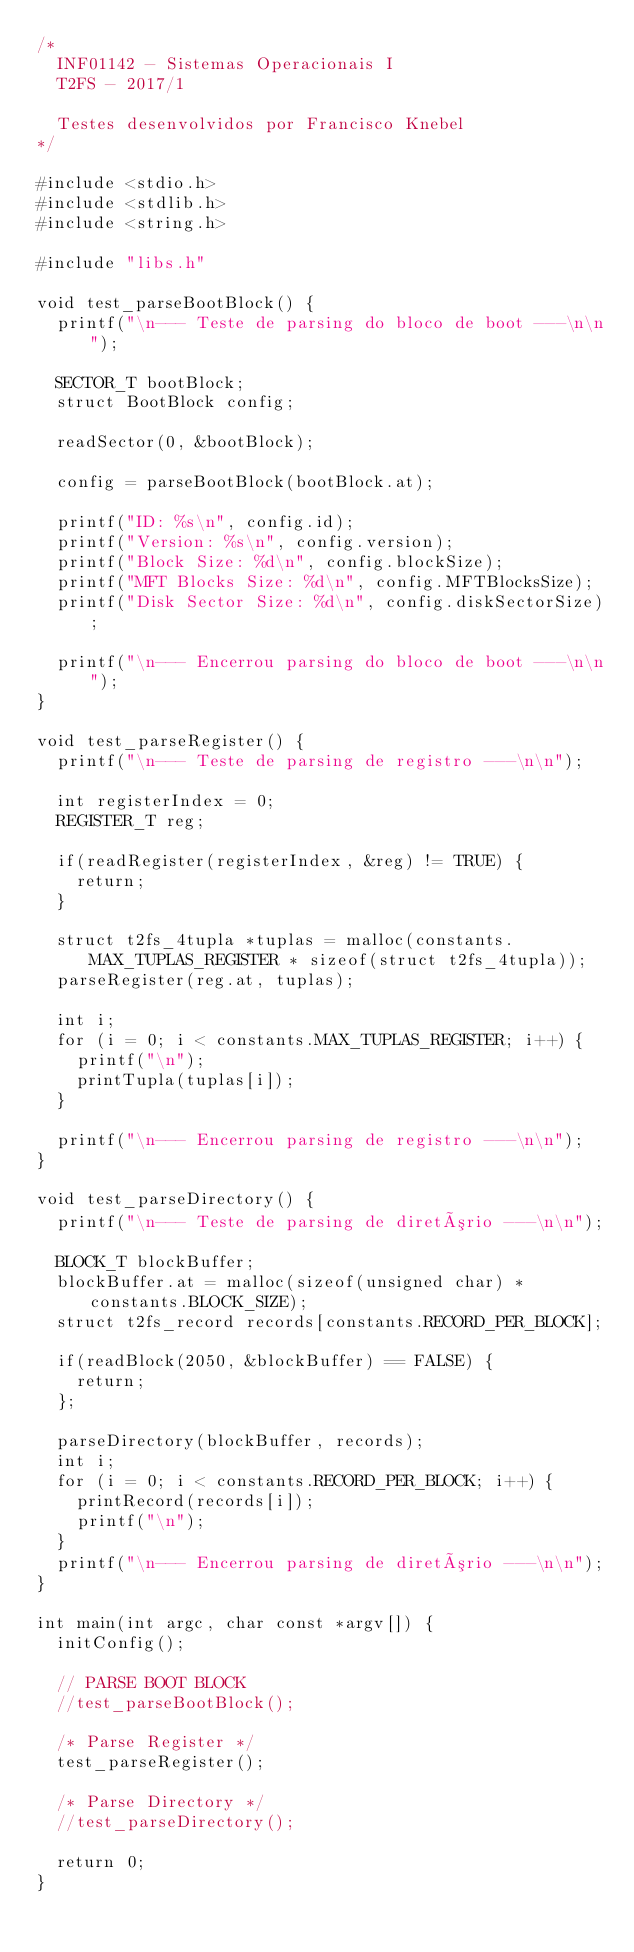Convert code to text. <code><loc_0><loc_0><loc_500><loc_500><_C_>/*
  INF01142 - Sistemas Operacionais I
  T2FS - 2017/1

  Testes desenvolvidos por Francisco Knebel
*/

#include <stdio.h>
#include <stdlib.h>
#include <string.h>

#include "libs.h"

void test_parseBootBlock() {
  printf("\n--- Teste de parsing do bloco de boot ---\n\n");

  SECTOR_T bootBlock;
  struct BootBlock config;

  readSector(0, &bootBlock);

  config = parseBootBlock(bootBlock.at);

  printf("ID: %s\n", config.id);
  printf("Version: %s\n", config.version);
  printf("Block Size: %d\n", config.blockSize);
  printf("MFT Blocks Size: %d\n", config.MFTBlocksSize);
  printf("Disk Sector Size: %d\n", config.diskSectorSize);

  printf("\n--- Encerrou parsing do bloco de boot ---\n\n");
}

void test_parseRegister() {
  printf("\n--- Teste de parsing de registro ---\n\n");

  int registerIndex = 0;
  REGISTER_T reg;

  if(readRegister(registerIndex, &reg) != TRUE) {
    return;
  }

  struct t2fs_4tupla *tuplas = malloc(constants.MAX_TUPLAS_REGISTER * sizeof(struct t2fs_4tupla));
  parseRegister(reg.at, tuplas);

  int i;
  for (i = 0; i < constants.MAX_TUPLAS_REGISTER; i++) {
    printf("\n");
    printTupla(tuplas[i]);
  }

  printf("\n--- Encerrou parsing de registro ---\n\n");
}

void test_parseDirectory() {
  printf("\n--- Teste de parsing de diretório ---\n\n");

  BLOCK_T blockBuffer;
  blockBuffer.at = malloc(sizeof(unsigned char) * constants.BLOCK_SIZE);
  struct t2fs_record records[constants.RECORD_PER_BLOCK];

  if(readBlock(2050, &blockBuffer) == FALSE) {
    return;
  };

  parseDirectory(blockBuffer, records);
  int i;
  for (i = 0; i < constants.RECORD_PER_BLOCK; i++) {
    printRecord(records[i]);
    printf("\n");
  }
  printf("\n--- Encerrou parsing de diretório ---\n\n");
}

int main(int argc, char const *argv[]) {
  initConfig();

  // PARSE BOOT BLOCK
  //test_parseBootBlock();

  /* Parse Register */
  test_parseRegister();

  /* Parse Directory */
  //test_parseDirectory();

  return 0;
}
</code> 